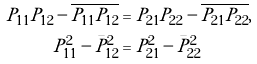Convert formula to latex. <formula><loc_0><loc_0><loc_500><loc_500>P _ { 1 1 } P _ { 1 2 } - \overline { P _ { 1 1 } P _ { 1 2 } } & = P _ { 2 1 } P _ { 2 2 } - \overline { P _ { 2 1 } P _ { 2 2 } } , \\ P _ { 1 1 } ^ { 2 } - \bar { P } _ { 1 2 } ^ { 2 } & = P _ { 2 1 } ^ { 2 } - \bar { P } _ { 2 2 } ^ { 2 }</formula> 